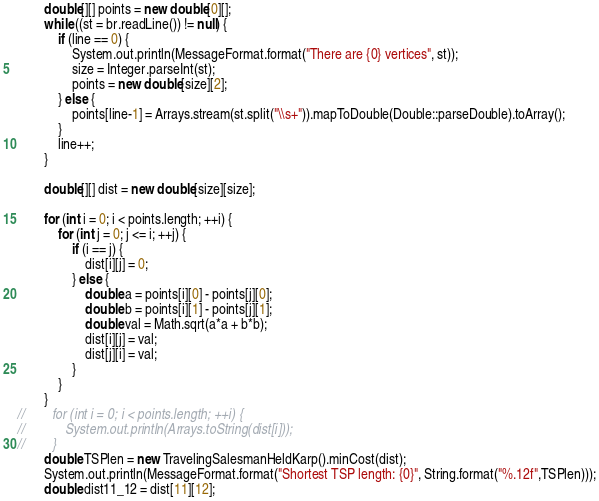<code> <loc_0><loc_0><loc_500><loc_500><_Java_>        double[][] points = new double[0][];
        while ((st = br.readLine()) != null) {
            if (line == 0) {
                System.out.println(MessageFormat.format("There are {0} vertices", st));
                size = Integer.parseInt(st);
                points = new double[size][2];
            } else {
                points[line-1] = Arrays.stream(st.split("\\s+")).mapToDouble(Double::parseDouble).toArray();
            }
            line++;
        }

        double[][] dist = new double[size][size];

        for (int i = 0; i < points.length; ++i) {
            for (int j = 0; j <= i; ++j) {
                if (i == j) {
                    dist[i][j] = 0;
                } else {
                    double a = points[i][0] - points[j][0];
                    double b = points[i][1] - points[j][1];
                    double val = Math.sqrt(a*a + b*b);
                    dist[i][j] = val;
                    dist[j][i] = val;
                }
            }
        }
//        for (int i = 0; i < points.length; ++i) {
//            System.out.println(Arrays.toString(dist[i]));
//        }
        double TSPlen = new TravelingSalesmanHeldKarp().minCost(dist);
        System.out.println(MessageFormat.format("Shortest TSP length: {0}", String.format("%.12f",TSPlen)));
        double dist11_12 = dist[11][12];</code> 